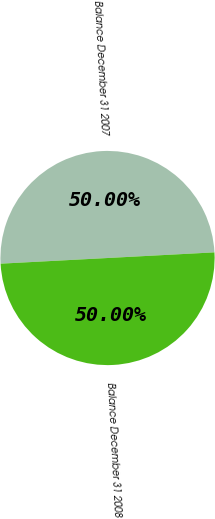Convert chart. <chart><loc_0><loc_0><loc_500><loc_500><pie_chart><fcel>Balance December 31 2007<fcel>Balance December 31 2008<nl><fcel>50.0%<fcel>50.0%<nl></chart> 